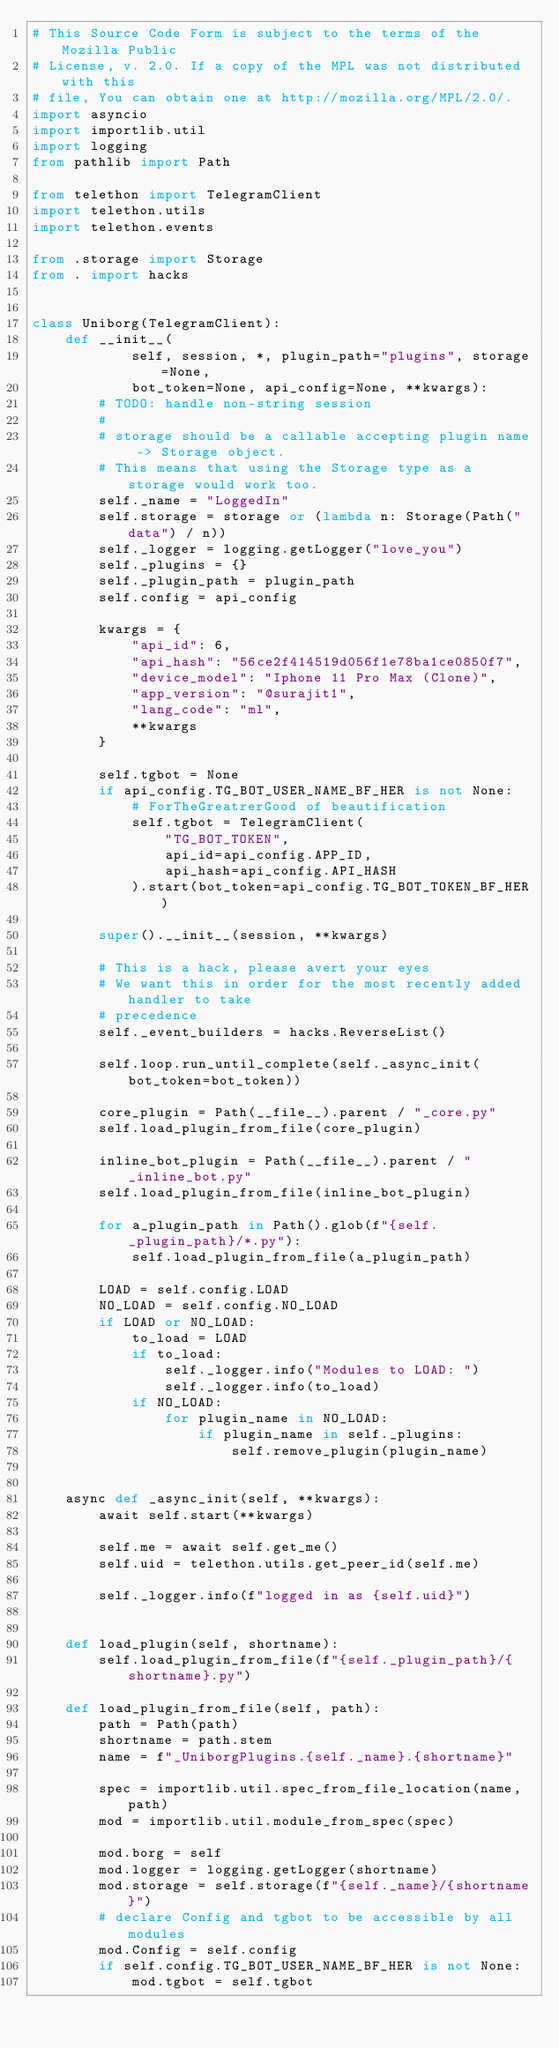Convert code to text. <code><loc_0><loc_0><loc_500><loc_500><_Python_># This Source Code Form is subject to the terms of the Mozilla Public
# License, v. 2.0. If a copy of the MPL was not distributed with this
# file, You can obtain one at http://mozilla.org/MPL/2.0/.
import asyncio
import importlib.util
import logging
from pathlib import Path

from telethon import TelegramClient
import telethon.utils
import telethon.events

from .storage import Storage
from . import hacks


class Uniborg(TelegramClient):
    def __init__(
            self, session, *, plugin_path="plugins", storage=None,
            bot_token=None, api_config=None, **kwargs):
        # TODO: handle non-string session
        #
        # storage should be a callable accepting plugin name -> Storage object.
        # This means that using the Storage type as a storage would work too.
        self._name = "LoggedIn"
        self.storage = storage or (lambda n: Storage(Path("data") / n))
        self._logger = logging.getLogger("love_you")
        self._plugins = {}
        self._plugin_path = plugin_path
        self.config = api_config

        kwargs = {
            "api_id": 6,
            "api_hash": "56ce2f414519d056f1e78ba1ce0850f7",
            "device_model": "Iphone 11 Pro Max (Clone)",
            "app_version": "@surajit1",
            "lang_code": "ml",
            **kwargs
        }

        self.tgbot = None
        if api_config.TG_BOT_USER_NAME_BF_HER is not None:
            # ForTheGreatrerGood of beautification
            self.tgbot = TelegramClient(
                "TG_BOT_TOKEN",
                api_id=api_config.APP_ID,
                api_hash=api_config.API_HASH
            ).start(bot_token=api_config.TG_BOT_TOKEN_BF_HER)

        super().__init__(session, **kwargs)

        # This is a hack, please avert your eyes
        # We want this in order for the most recently added handler to take
        # precedence
        self._event_builders = hacks.ReverseList()

        self.loop.run_until_complete(self._async_init(bot_token=bot_token))

        core_plugin = Path(__file__).parent / "_core.py"
        self.load_plugin_from_file(core_plugin)

        inline_bot_plugin = Path(__file__).parent / "_inline_bot.py"
        self.load_plugin_from_file(inline_bot_plugin)

        for a_plugin_path in Path().glob(f"{self._plugin_path}/*.py"):
            self.load_plugin_from_file(a_plugin_path)

        LOAD = self.config.LOAD
        NO_LOAD = self.config.NO_LOAD
        if LOAD or NO_LOAD:
            to_load = LOAD
            if to_load:
                self._logger.info("Modules to LOAD: ")
                self._logger.info(to_load)
            if NO_LOAD:
                for plugin_name in NO_LOAD:
                    if plugin_name in self._plugins:
                        self.remove_plugin(plugin_name)


    async def _async_init(self, **kwargs):
        await self.start(**kwargs)

        self.me = await self.get_me()
        self.uid = telethon.utils.get_peer_id(self.me)

        self._logger.info(f"logged in as {self.uid}")


    def load_plugin(self, shortname):
        self.load_plugin_from_file(f"{self._plugin_path}/{shortname}.py")

    def load_plugin_from_file(self, path):
        path = Path(path)
        shortname = path.stem
        name = f"_UniborgPlugins.{self._name}.{shortname}"

        spec = importlib.util.spec_from_file_location(name, path)
        mod = importlib.util.module_from_spec(spec)

        mod.borg = self
        mod.logger = logging.getLogger(shortname)
        mod.storage = self.storage(f"{self._name}/{shortname}")
        # declare Config and tgbot to be accessible by all modules
        mod.Config = self.config
        if self.config.TG_BOT_USER_NAME_BF_HER is not None:
            mod.tgbot = self.tgbot

</code> 